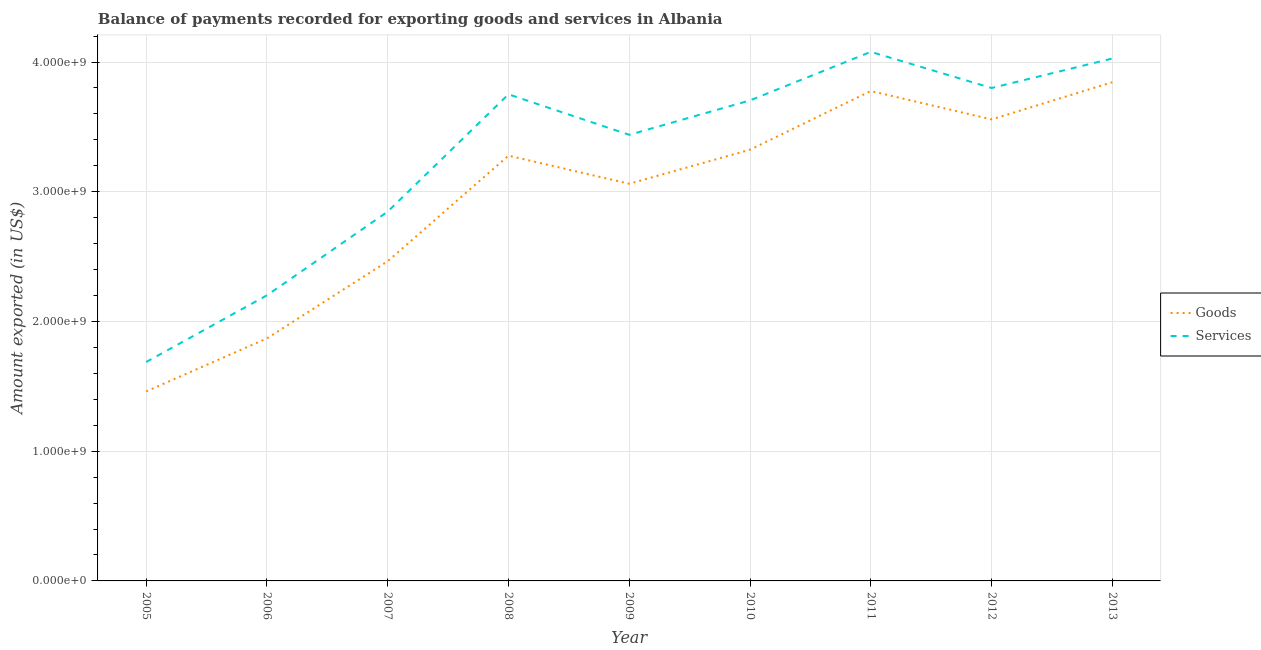How many different coloured lines are there?
Make the answer very short. 2. Does the line corresponding to amount of goods exported intersect with the line corresponding to amount of services exported?
Your response must be concise. No. Is the number of lines equal to the number of legend labels?
Provide a succinct answer. Yes. What is the amount of goods exported in 2012?
Keep it short and to the point. 3.56e+09. Across all years, what is the maximum amount of goods exported?
Provide a succinct answer. 3.84e+09. Across all years, what is the minimum amount of goods exported?
Your answer should be compact. 1.46e+09. In which year was the amount of goods exported minimum?
Offer a very short reply. 2005. What is the total amount of services exported in the graph?
Offer a very short reply. 2.95e+1. What is the difference between the amount of services exported in 2008 and that in 2011?
Your answer should be very brief. -3.27e+08. What is the difference between the amount of goods exported in 2013 and the amount of services exported in 2009?
Provide a succinct answer. 4.05e+08. What is the average amount of services exported per year?
Keep it short and to the point. 3.28e+09. In the year 2006, what is the difference between the amount of services exported and amount of goods exported?
Offer a terse response. 3.32e+08. In how many years, is the amount of services exported greater than 1800000000 US$?
Give a very brief answer. 8. What is the ratio of the amount of goods exported in 2005 to that in 2013?
Give a very brief answer. 0.38. Is the amount of goods exported in 2008 less than that in 2010?
Make the answer very short. Yes. What is the difference between the highest and the second highest amount of goods exported?
Offer a terse response. 6.77e+07. What is the difference between the highest and the lowest amount of services exported?
Make the answer very short. 2.39e+09. Is the sum of the amount of goods exported in 2005 and 2012 greater than the maximum amount of services exported across all years?
Your response must be concise. Yes. Is the amount of services exported strictly less than the amount of goods exported over the years?
Provide a short and direct response. No. What is the difference between two consecutive major ticks on the Y-axis?
Offer a terse response. 1.00e+09. Are the values on the major ticks of Y-axis written in scientific E-notation?
Keep it short and to the point. Yes. Does the graph contain any zero values?
Keep it short and to the point. No. Does the graph contain grids?
Provide a short and direct response. Yes. What is the title of the graph?
Offer a terse response. Balance of payments recorded for exporting goods and services in Albania. What is the label or title of the Y-axis?
Provide a short and direct response. Amount exported (in US$). What is the Amount exported (in US$) in Goods in 2005?
Your answer should be very brief. 1.46e+09. What is the Amount exported (in US$) in Services in 2005?
Provide a short and direct response. 1.69e+09. What is the Amount exported (in US$) of Goods in 2006?
Offer a terse response. 1.87e+09. What is the Amount exported (in US$) in Services in 2006?
Offer a very short reply. 2.20e+09. What is the Amount exported (in US$) in Goods in 2007?
Keep it short and to the point. 2.46e+09. What is the Amount exported (in US$) of Services in 2007?
Your response must be concise. 2.85e+09. What is the Amount exported (in US$) in Goods in 2008?
Make the answer very short. 3.28e+09. What is the Amount exported (in US$) in Services in 2008?
Keep it short and to the point. 3.75e+09. What is the Amount exported (in US$) in Goods in 2009?
Make the answer very short. 3.06e+09. What is the Amount exported (in US$) of Services in 2009?
Make the answer very short. 3.44e+09. What is the Amount exported (in US$) of Goods in 2010?
Make the answer very short. 3.32e+09. What is the Amount exported (in US$) in Services in 2010?
Your answer should be compact. 3.70e+09. What is the Amount exported (in US$) in Goods in 2011?
Offer a very short reply. 3.78e+09. What is the Amount exported (in US$) of Services in 2011?
Your answer should be compact. 4.08e+09. What is the Amount exported (in US$) of Goods in 2012?
Provide a short and direct response. 3.56e+09. What is the Amount exported (in US$) of Services in 2012?
Your response must be concise. 3.80e+09. What is the Amount exported (in US$) in Goods in 2013?
Your answer should be compact. 3.84e+09. What is the Amount exported (in US$) in Services in 2013?
Provide a succinct answer. 4.03e+09. Across all years, what is the maximum Amount exported (in US$) in Goods?
Make the answer very short. 3.84e+09. Across all years, what is the maximum Amount exported (in US$) of Services?
Offer a very short reply. 4.08e+09. Across all years, what is the minimum Amount exported (in US$) of Goods?
Provide a succinct answer. 1.46e+09. Across all years, what is the minimum Amount exported (in US$) in Services?
Provide a succinct answer. 1.69e+09. What is the total Amount exported (in US$) of Goods in the graph?
Offer a very short reply. 2.66e+1. What is the total Amount exported (in US$) in Services in the graph?
Provide a succinct answer. 2.95e+1. What is the difference between the Amount exported (in US$) in Goods in 2005 and that in 2006?
Provide a succinct answer. -4.09e+08. What is the difference between the Amount exported (in US$) of Services in 2005 and that in 2006?
Offer a terse response. -5.14e+08. What is the difference between the Amount exported (in US$) of Goods in 2005 and that in 2007?
Your answer should be very brief. -1.00e+09. What is the difference between the Amount exported (in US$) of Services in 2005 and that in 2007?
Keep it short and to the point. -1.16e+09. What is the difference between the Amount exported (in US$) in Goods in 2005 and that in 2008?
Make the answer very short. -1.82e+09. What is the difference between the Amount exported (in US$) of Services in 2005 and that in 2008?
Offer a very short reply. -2.06e+09. What is the difference between the Amount exported (in US$) in Goods in 2005 and that in 2009?
Your answer should be very brief. -1.60e+09. What is the difference between the Amount exported (in US$) of Services in 2005 and that in 2009?
Keep it short and to the point. -1.75e+09. What is the difference between the Amount exported (in US$) in Goods in 2005 and that in 2010?
Your answer should be very brief. -1.86e+09. What is the difference between the Amount exported (in US$) in Services in 2005 and that in 2010?
Give a very brief answer. -2.02e+09. What is the difference between the Amount exported (in US$) of Goods in 2005 and that in 2011?
Provide a short and direct response. -2.32e+09. What is the difference between the Amount exported (in US$) in Services in 2005 and that in 2011?
Your answer should be compact. -2.39e+09. What is the difference between the Amount exported (in US$) in Goods in 2005 and that in 2012?
Give a very brief answer. -2.10e+09. What is the difference between the Amount exported (in US$) of Services in 2005 and that in 2012?
Provide a short and direct response. -2.11e+09. What is the difference between the Amount exported (in US$) in Goods in 2005 and that in 2013?
Ensure brevity in your answer.  -2.38e+09. What is the difference between the Amount exported (in US$) of Services in 2005 and that in 2013?
Provide a short and direct response. -2.34e+09. What is the difference between the Amount exported (in US$) in Goods in 2006 and that in 2007?
Provide a short and direct response. -5.95e+08. What is the difference between the Amount exported (in US$) in Services in 2006 and that in 2007?
Offer a very short reply. -6.45e+08. What is the difference between the Amount exported (in US$) of Goods in 2006 and that in 2008?
Provide a succinct answer. -1.41e+09. What is the difference between the Amount exported (in US$) of Services in 2006 and that in 2008?
Make the answer very short. -1.55e+09. What is the difference between the Amount exported (in US$) of Goods in 2006 and that in 2009?
Your response must be concise. -1.19e+09. What is the difference between the Amount exported (in US$) of Services in 2006 and that in 2009?
Provide a short and direct response. -1.24e+09. What is the difference between the Amount exported (in US$) of Goods in 2006 and that in 2010?
Your response must be concise. -1.45e+09. What is the difference between the Amount exported (in US$) in Services in 2006 and that in 2010?
Your response must be concise. -1.50e+09. What is the difference between the Amount exported (in US$) of Goods in 2006 and that in 2011?
Offer a terse response. -1.91e+09. What is the difference between the Amount exported (in US$) of Services in 2006 and that in 2011?
Your answer should be compact. -1.88e+09. What is the difference between the Amount exported (in US$) of Goods in 2006 and that in 2012?
Your answer should be compact. -1.69e+09. What is the difference between the Amount exported (in US$) of Services in 2006 and that in 2012?
Your response must be concise. -1.60e+09. What is the difference between the Amount exported (in US$) in Goods in 2006 and that in 2013?
Ensure brevity in your answer.  -1.97e+09. What is the difference between the Amount exported (in US$) of Services in 2006 and that in 2013?
Ensure brevity in your answer.  -1.83e+09. What is the difference between the Amount exported (in US$) in Goods in 2007 and that in 2008?
Ensure brevity in your answer.  -8.14e+08. What is the difference between the Amount exported (in US$) in Services in 2007 and that in 2008?
Ensure brevity in your answer.  -9.04e+08. What is the difference between the Amount exported (in US$) in Goods in 2007 and that in 2009?
Offer a terse response. -5.97e+08. What is the difference between the Amount exported (in US$) of Services in 2007 and that in 2009?
Make the answer very short. -5.92e+08. What is the difference between the Amount exported (in US$) in Goods in 2007 and that in 2010?
Your answer should be very brief. -8.60e+08. What is the difference between the Amount exported (in US$) in Services in 2007 and that in 2010?
Offer a terse response. -8.57e+08. What is the difference between the Amount exported (in US$) in Goods in 2007 and that in 2011?
Your answer should be very brief. -1.31e+09. What is the difference between the Amount exported (in US$) in Services in 2007 and that in 2011?
Offer a terse response. -1.23e+09. What is the difference between the Amount exported (in US$) in Goods in 2007 and that in 2012?
Provide a short and direct response. -1.09e+09. What is the difference between the Amount exported (in US$) of Services in 2007 and that in 2012?
Your response must be concise. -9.53e+08. What is the difference between the Amount exported (in US$) in Goods in 2007 and that in 2013?
Make the answer very short. -1.38e+09. What is the difference between the Amount exported (in US$) of Services in 2007 and that in 2013?
Offer a terse response. -1.18e+09. What is the difference between the Amount exported (in US$) in Goods in 2008 and that in 2009?
Your response must be concise. 2.17e+08. What is the difference between the Amount exported (in US$) of Services in 2008 and that in 2009?
Ensure brevity in your answer.  3.12e+08. What is the difference between the Amount exported (in US$) of Goods in 2008 and that in 2010?
Make the answer very short. -4.58e+07. What is the difference between the Amount exported (in US$) in Services in 2008 and that in 2010?
Ensure brevity in your answer.  4.71e+07. What is the difference between the Amount exported (in US$) of Goods in 2008 and that in 2011?
Ensure brevity in your answer.  -4.98e+08. What is the difference between the Amount exported (in US$) in Services in 2008 and that in 2011?
Offer a very short reply. -3.27e+08. What is the difference between the Amount exported (in US$) in Goods in 2008 and that in 2012?
Give a very brief answer. -2.79e+08. What is the difference between the Amount exported (in US$) of Services in 2008 and that in 2012?
Give a very brief answer. -4.85e+07. What is the difference between the Amount exported (in US$) of Goods in 2008 and that in 2013?
Keep it short and to the point. -5.66e+08. What is the difference between the Amount exported (in US$) of Services in 2008 and that in 2013?
Your answer should be very brief. -2.76e+08. What is the difference between the Amount exported (in US$) in Goods in 2009 and that in 2010?
Offer a terse response. -2.63e+08. What is the difference between the Amount exported (in US$) of Services in 2009 and that in 2010?
Give a very brief answer. -2.65e+08. What is the difference between the Amount exported (in US$) in Goods in 2009 and that in 2011?
Offer a terse response. -7.15e+08. What is the difference between the Amount exported (in US$) of Services in 2009 and that in 2011?
Ensure brevity in your answer.  -6.39e+08. What is the difference between the Amount exported (in US$) of Goods in 2009 and that in 2012?
Your answer should be very brief. -4.96e+08. What is the difference between the Amount exported (in US$) in Services in 2009 and that in 2012?
Ensure brevity in your answer.  -3.61e+08. What is the difference between the Amount exported (in US$) in Goods in 2009 and that in 2013?
Give a very brief answer. -7.83e+08. What is the difference between the Amount exported (in US$) of Services in 2009 and that in 2013?
Provide a short and direct response. -5.88e+08. What is the difference between the Amount exported (in US$) of Goods in 2010 and that in 2011?
Offer a very short reply. -4.52e+08. What is the difference between the Amount exported (in US$) of Services in 2010 and that in 2011?
Provide a succinct answer. -3.74e+08. What is the difference between the Amount exported (in US$) in Goods in 2010 and that in 2012?
Provide a succinct answer. -2.33e+08. What is the difference between the Amount exported (in US$) in Services in 2010 and that in 2012?
Your answer should be very brief. -9.56e+07. What is the difference between the Amount exported (in US$) of Goods in 2010 and that in 2013?
Ensure brevity in your answer.  -5.20e+08. What is the difference between the Amount exported (in US$) in Services in 2010 and that in 2013?
Your response must be concise. -3.23e+08. What is the difference between the Amount exported (in US$) in Goods in 2011 and that in 2012?
Keep it short and to the point. 2.19e+08. What is the difference between the Amount exported (in US$) in Services in 2011 and that in 2012?
Provide a short and direct response. 2.79e+08. What is the difference between the Amount exported (in US$) in Goods in 2011 and that in 2013?
Offer a very short reply. -6.77e+07. What is the difference between the Amount exported (in US$) of Services in 2011 and that in 2013?
Give a very brief answer. 5.13e+07. What is the difference between the Amount exported (in US$) of Goods in 2012 and that in 2013?
Provide a succinct answer. -2.87e+08. What is the difference between the Amount exported (in US$) of Services in 2012 and that in 2013?
Ensure brevity in your answer.  -2.27e+08. What is the difference between the Amount exported (in US$) in Goods in 2005 and the Amount exported (in US$) in Services in 2006?
Provide a short and direct response. -7.41e+08. What is the difference between the Amount exported (in US$) in Goods in 2005 and the Amount exported (in US$) in Services in 2007?
Ensure brevity in your answer.  -1.39e+09. What is the difference between the Amount exported (in US$) in Goods in 2005 and the Amount exported (in US$) in Services in 2008?
Offer a very short reply. -2.29e+09. What is the difference between the Amount exported (in US$) in Goods in 2005 and the Amount exported (in US$) in Services in 2009?
Offer a terse response. -1.98e+09. What is the difference between the Amount exported (in US$) of Goods in 2005 and the Amount exported (in US$) of Services in 2010?
Your answer should be compact. -2.24e+09. What is the difference between the Amount exported (in US$) in Goods in 2005 and the Amount exported (in US$) in Services in 2011?
Your response must be concise. -2.62e+09. What is the difference between the Amount exported (in US$) in Goods in 2005 and the Amount exported (in US$) in Services in 2012?
Make the answer very short. -2.34e+09. What is the difference between the Amount exported (in US$) of Goods in 2005 and the Amount exported (in US$) of Services in 2013?
Keep it short and to the point. -2.57e+09. What is the difference between the Amount exported (in US$) of Goods in 2006 and the Amount exported (in US$) of Services in 2007?
Provide a succinct answer. -9.77e+08. What is the difference between the Amount exported (in US$) in Goods in 2006 and the Amount exported (in US$) in Services in 2008?
Provide a short and direct response. -1.88e+09. What is the difference between the Amount exported (in US$) of Goods in 2006 and the Amount exported (in US$) of Services in 2009?
Your answer should be compact. -1.57e+09. What is the difference between the Amount exported (in US$) in Goods in 2006 and the Amount exported (in US$) in Services in 2010?
Offer a terse response. -1.83e+09. What is the difference between the Amount exported (in US$) in Goods in 2006 and the Amount exported (in US$) in Services in 2011?
Make the answer very short. -2.21e+09. What is the difference between the Amount exported (in US$) in Goods in 2006 and the Amount exported (in US$) in Services in 2012?
Keep it short and to the point. -1.93e+09. What is the difference between the Amount exported (in US$) in Goods in 2006 and the Amount exported (in US$) in Services in 2013?
Your answer should be very brief. -2.16e+09. What is the difference between the Amount exported (in US$) of Goods in 2007 and the Amount exported (in US$) of Services in 2008?
Keep it short and to the point. -1.29e+09. What is the difference between the Amount exported (in US$) in Goods in 2007 and the Amount exported (in US$) in Services in 2009?
Give a very brief answer. -9.74e+08. What is the difference between the Amount exported (in US$) in Goods in 2007 and the Amount exported (in US$) in Services in 2010?
Your answer should be very brief. -1.24e+09. What is the difference between the Amount exported (in US$) in Goods in 2007 and the Amount exported (in US$) in Services in 2011?
Your response must be concise. -1.61e+09. What is the difference between the Amount exported (in US$) in Goods in 2007 and the Amount exported (in US$) in Services in 2012?
Keep it short and to the point. -1.34e+09. What is the difference between the Amount exported (in US$) of Goods in 2007 and the Amount exported (in US$) of Services in 2013?
Ensure brevity in your answer.  -1.56e+09. What is the difference between the Amount exported (in US$) of Goods in 2008 and the Amount exported (in US$) of Services in 2009?
Offer a very short reply. -1.61e+08. What is the difference between the Amount exported (in US$) of Goods in 2008 and the Amount exported (in US$) of Services in 2010?
Your answer should be compact. -4.26e+08. What is the difference between the Amount exported (in US$) in Goods in 2008 and the Amount exported (in US$) in Services in 2011?
Offer a very short reply. -8.00e+08. What is the difference between the Amount exported (in US$) in Goods in 2008 and the Amount exported (in US$) in Services in 2012?
Ensure brevity in your answer.  -5.21e+08. What is the difference between the Amount exported (in US$) in Goods in 2008 and the Amount exported (in US$) in Services in 2013?
Offer a very short reply. -7.49e+08. What is the difference between the Amount exported (in US$) of Goods in 2009 and the Amount exported (in US$) of Services in 2010?
Your response must be concise. -6.43e+08. What is the difference between the Amount exported (in US$) of Goods in 2009 and the Amount exported (in US$) of Services in 2011?
Your answer should be compact. -1.02e+09. What is the difference between the Amount exported (in US$) of Goods in 2009 and the Amount exported (in US$) of Services in 2012?
Give a very brief answer. -7.38e+08. What is the difference between the Amount exported (in US$) of Goods in 2009 and the Amount exported (in US$) of Services in 2013?
Provide a short and direct response. -9.66e+08. What is the difference between the Amount exported (in US$) in Goods in 2010 and the Amount exported (in US$) in Services in 2011?
Your answer should be compact. -7.54e+08. What is the difference between the Amount exported (in US$) in Goods in 2010 and the Amount exported (in US$) in Services in 2012?
Your answer should be compact. -4.76e+08. What is the difference between the Amount exported (in US$) in Goods in 2010 and the Amount exported (in US$) in Services in 2013?
Give a very brief answer. -7.03e+08. What is the difference between the Amount exported (in US$) of Goods in 2011 and the Amount exported (in US$) of Services in 2012?
Make the answer very short. -2.32e+07. What is the difference between the Amount exported (in US$) in Goods in 2011 and the Amount exported (in US$) in Services in 2013?
Offer a terse response. -2.51e+08. What is the difference between the Amount exported (in US$) in Goods in 2012 and the Amount exported (in US$) in Services in 2013?
Keep it short and to the point. -4.69e+08. What is the average Amount exported (in US$) of Goods per year?
Make the answer very short. 2.96e+09. What is the average Amount exported (in US$) in Services per year?
Offer a terse response. 3.28e+09. In the year 2005, what is the difference between the Amount exported (in US$) of Goods and Amount exported (in US$) of Services?
Your answer should be very brief. -2.27e+08. In the year 2006, what is the difference between the Amount exported (in US$) in Goods and Amount exported (in US$) in Services?
Provide a short and direct response. -3.32e+08. In the year 2007, what is the difference between the Amount exported (in US$) of Goods and Amount exported (in US$) of Services?
Your answer should be compact. -3.82e+08. In the year 2008, what is the difference between the Amount exported (in US$) in Goods and Amount exported (in US$) in Services?
Provide a succinct answer. -4.73e+08. In the year 2009, what is the difference between the Amount exported (in US$) of Goods and Amount exported (in US$) of Services?
Provide a succinct answer. -3.77e+08. In the year 2010, what is the difference between the Amount exported (in US$) of Goods and Amount exported (in US$) of Services?
Your response must be concise. -3.80e+08. In the year 2011, what is the difference between the Amount exported (in US$) of Goods and Amount exported (in US$) of Services?
Your response must be concise. -3.02e+08. In the year 2012, what is the difference between the Amount exported (in US$) in Goods and Amount exported (in US$) in Services?
Your answer should be very brief. -2.42e+08. In the year 2013, what is the difference between the Amount exported (in US$) of Goods and Amount exported (in US$) of Services?
Give a very brief answer. -1.83e+08. What is the ratio of the Amount exported (in US$) in Goods in 2005 to that in 2006?
Your answer should be compact. 0.78. What is the ratio of the Amount exported (in US$) of Services in 2005 to that in 2006?
Make the answer very short. 0.77. What is the ratio of the Amount exported (in US$) of Goods in 2005 to that in 2007?
Your answer should be compact. 0.59. What is the ratio of the Amount exported (in US$) in Services in 2005 to that in 2007?
Your answer should be very brief. 0.59. What is the ratio of the Amount exported (in US$) of Goods in 2005 to that in 2008?
Provide a short and direct response. 0.45. What is the ratio of the Amount exported (in US$) in Services in 2005 to that in 2008?
Provide a succinct answer. 0.45. What is the ratio of the Amount exported (in US$) in Goods in 2005 to that in 2009?
Give a very brief answer. 0.48. What is the ratio of the Amount exported (in US$) of Services in 2005 to that in 2009?
Keep it short and to the point. 0.49. What is the ratio of the Amount exported (in US$) in Goods in 2005 to that in 2010?
Your answer should be very brief. 0.44. What is the ratio of the Amount exported (in US$) of Services in 2005 to that in 2010?
Offer a very short reply. 0.46. What is the ratio of the Amount exported (in US$) in Goods in 2005 to that in 2011?
Your answer should be compact. 0.39. What is the ratio of the Amount exported (in US$) in Services in 2005 to that in 2011?
Your answer should be very brief. 0.41. What is the ratio of the Amount exported (in US$) in Goods in 2005 to that in 2012?
Make the answer very short. 0.41. What is the ratio of the Amount exported (in US$) of Services in 2005 to that in 2012?
Keep it short and to the point. 0.44. What is the ratio of the Amount exported (in US$) of Goods in 2005 to that in 2013?
Offer a very short reply. 0.38. What is the ratio of the Amount exported (in US$) of Services in 2005 to that in 2013?
Give a very brief answer. 0.42. What is the ratio of the Amount exported (in US$) of Goods in 2006 to that in 2007?
Your response must be concise. 0.76. What is the ratio of the Amount exported (in US$) in Services in 2006 to that in 2007?
Ensure brevity in your answer.  0.77. What is the ratio of the Amount exported (in US$) of Goods in 2006 to that in 2008?
Offer a terse response. 0.57. What is the ratio of the Amount exported (in US$) in Services in 2006 to that in 2008?
Ensure brevity in your answer.  0.59. What is the ratio of the Amount exported (in US$) in Goods in 2006 to that in 2009?
Keep it short and to the point. 0.61. What is the ratio of the Amount exported (in US$) of Services in 2006 to that in 2009?
Provide a succinct answer. 0.64. What is the ratio of the Amount exported (in US$) of Goods in 2006 to that in 2010?
Your answer should be compact. 0.56. What is the ratio of the Amount exported (in US$) in Services in 2006 to that in 2010?
Ensure brevity in your answer.  0.59. What is the ratio of the Amount exported (in US$) of Goods in 2006 to that in 2011?
Provide a short and direct response. 0.5. What is the ratio of the Amount exported (in US$) in Services in 2006 to that in 2011?
Your response must be concise. 0.54. What is the ratio of the Amount exported (in US$) in Goods in 2006 to that in 2012?
Make the answer very short. 0.53. What is the ratio of the Amount exported (in US$) in Services in 2006 to that in 2012?
Provide a short and direct response. 0.58. What is the ratio of the Amount exported (in US$) in Goods in 2006 to that in 2013?
Your answer should be very brief. 0.49. What is the ratio of the Amount exported (in US$) in Services in 2006 to that in 2013?
Your answer should be very brief. 0.55. What is the ratio of the Amount exported (in US$) in Goods in 2007 to that in 2008?
Offer a terse response. 0.75. What is the ratio of the Amount exported (in US$) in Services in 2007 to that in 2008?
Provide a succinct answer. 0.76. What is the ratio of the Amount exported (in US$) of Goods in 2007 to that in 2009?
Ensure brevity in your answer.  0.81. What is the ratio of the Amount exported (in US$) in Services in 2007 to that in 2009?
Offer a terse response. 0.83. What is the ratio of the Amount exported (in US$) in Goods in 2007 to that in 2010?
Make the answer very short. 0.74. What is the ratio of the Amount exported (in US$) in Services in 2007 to that in 2010?
Your answer should be compact. 0.77. What is the ratio of the Amount exported (in US$) of Goods in 2007 to that in 2011?
Give a very brief answer. 0.65. What is the ratio of the Amount exported (in US$) of Services in 2007 to that in 2011?
Offer a very short reply. 0.7. What is the ratio of the Amount exported (in US$) of Goods in 2007 to that in 2012?
Your answer should be very brief. 0.69. What is the ratio of the Amount exported (in US$) of Services in 2007 to that in 2012?
Provide a short and direct response. 0.75. What is the ratio of the Amount exported (in US$) of Goods in 2007 to that in 2013?
Your answer should be very brief. 0.64. What is the ratio of the Amount exported (in US$) in Services in 2007 to that in 2013?
Your answer should be very brief. 0.71. What is the ratio of the Amount exported (in US$) of Goods in 2008 to that in 2009?
Your answer should be compact. 1.07. What is the ratio of the Amount exported (in US$) in Services in 2008 to that in 2009?
Keep it short and to the point. 1.09. What is the ratio of the Amount exported (in US$) in Goods in 2008 to that in 2010?
Your answer should be very brief. 0.99. What is the ratio of the Amount exported (in US$) in Services in 2008 to that in 2010?
Make the answer very short. 1.01. What is the ratio of the Amount exported (in US$) in Goods in 2008 to that in 2011?
Your answer should be compact. 0.87. What is the ratio of the Amount exported (in US$) in Services in 2008 to that in 2011?
Your response must be concise. 0.92. What is the ratio of the Amount exported (in US$) in Goods in 2008 to that in 2012?
Offer a very short reply. 0.92. What is the ratio of the Amount exported (in US$) of Services in 2008 to that in 2012?
Your answer should be very brief. 0.99. What is the ratio of the Amount exported (in US$) in Goods in 2008 to that in 2013?
Offer a terse response. 0.85. What is the ratio of the Amount exported (in US$) of Services in 2008 to that in 2013?
Your answer should be compact. 0.93. What is the ratio of the Amount exported (in US$) in Goods in 2009 to that in 2010?
Give a very brief answer. 0.92. What is the ratio of the Amount exported (in US$) of Services in 2009 to that in 2010?
Ensure brevity in your answer.  0.93. What is the ratio of the Amount exported (in US$) in Goods in 2009 to that in 2011?
Offer a very short reply. 0.81. What is the ratio of the Amount exported (in US$) of Services in 2009 to that in 2011?
Provide a succinct answer. 0.84. What is the ratio of the Amount exported (in US$) in Goods in 2009 to that in 2012?
Offer a terse response. 0.86. What is the ratio of the Amount exported (in US$) in Services in 2009 to that in 2012?
Offer a very short reply. 0.91. What is the ratio of the Amount exported (in US$) in Goods in 2009 to that in 2013?
Provide a short and direct response. 0.8. What is the ratio of the Amount exported (in US$) of Services in 2009 to that in 2013?
Give a very brief answer. 0.85. What is the ratio of the Amount exported (in US$) of Goods in 2010 to that in 2011?
Offer a very short reply. 0.88. What is the ratio of the Amount exported (in US$) in Services in 2010 to that in 2011?
Offer a terse response. 0.91. What is the ratio of the Amount exported (in US$) in Goods in 2010 to that in 2012?
Keep it short and to the point. 0.93. What is the ratio of the Amount exported (in US$) in Services in 2010 to that in 2012?
Your answer should be compact. 0.97. What is the ratio of the Amount exported (in US$) of Goods in 2010 to that in 2013?
Your answer should be very brief. 0.86. What is the ratio of the Amount exported (in US$) of Services in 2010 to that in 2013?
Make the answer very short. 0.92. What is the ratio of the Amount exported (in US$) of Goods in 2011 to that in 2012?
Provide a short and direct response. 1.06. What is the ratio of the Amount exported (in US$) of Services in 2011 to that in 2012?
Provide a short and direct response. 1.07. What is the ratio of the Amount exported (in US$) of Goods in 2011 to that in 2013?
Your response must be concise. 0.98. What is the ratio of the Amount exported (in US$) of Services in 2011 to that in 2013?
Offer a terse response. 1.01. What is the ratio of the Amount exported (in US$) of Goods in 2012 to that in 2013?
Ensure brevity in your answer.  0.93. What is the ratio of the Amount exported (in US$) in Services in 2012 to that in 2013?
Keep it short and to the point. 0.94. What is the difference between the highest and the second highest Amount exported (in US$) of Goods?
Offer a very short reply. 6.77e+07. What is the difference between the highest and the second highest Amount exported (in US$) of Services?
Offer a very short reply. 5.13e+07. What is the difference between the highest and the lowest Amount exported (in US$) of Goods?
Ensure brevity in your answer.  2.38e+09. What is the difference between the highest and the lowest Amount exported (in US$) in Services?
Ensure brevity in your answer.  2.39e+09. 